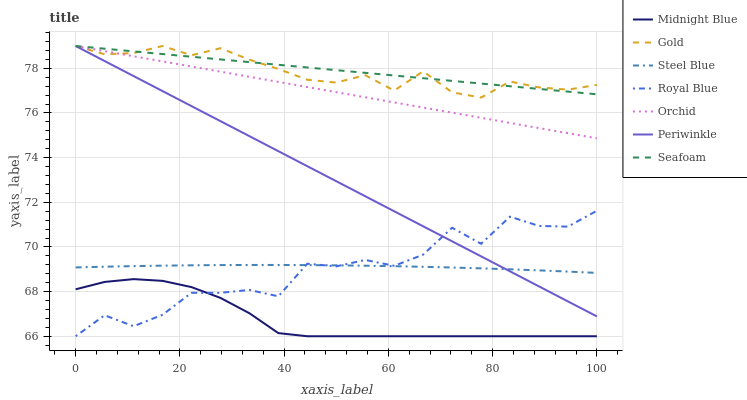Does Midnight Blue have the minimum area under the curve?
Answer yes or no. Yes. Does Seafoam have the maximum area under the curve?
Answer yes or no. Yes. Does Gold have the minimum area under the curve?
Answer yes or no. No. Does Gold have the maximum area under the curve?
Answer yes or no. No. Is Seafoam the smoothest?
Answer yes or no. Yes. Is Royal Blue the roughest?
Answer yes or no. Yes. Is Gold the smoothest?
Answer yes or no. No. Is Gold the roughest?
Answer yes or no. No. Does Midnight Blue have the lowest value?
Answer yes or no. Yes. Does Gold have the lowest value?
Answer yes or no. No. Does Orchid have the highest value?
Answer yes or no. Yes. Does Steel Blue have the highest value?
Answer yes or no. No. Is Steel Blue less than Gold?
Answer yes or no. Yes. Is Orchid greater than Royal Blue?
Answer yes or no. Yes. Does Periwinkle intersect Royal Blue?
Answer yes or no. Yes. Is Periwinkle less than Royal Blue?
Answer yes or no. No. Is Periwinkle greater than Royal Blue?
Answer yes or no. No. Does Steel Blue intersect Gold?
Answer yes or no. No. 